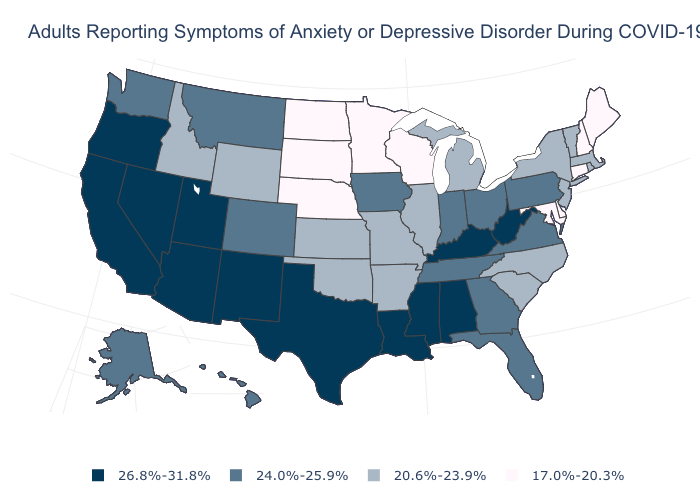Does Virginia have a lower value than Georgia?
Concise answer only. No. What is the value of Alaska?
Give a very brief answer. 24.0%-25.9%. Which states have the highest value in the USA?
Answer briefly. Alabama, Arizona, California, Kentucky, Louisiana, Mississippi, Nevada, New Mexico, Oregon, Texas, Utah, West Virginia. Does Kentucky have a higher value than Indiana?
Answer briefly. Yes. What is the value of Wyoming?
Keep it brief. 20.6%-23.9%. Name the states that have a value in the range 26.8%-31.8%?
Write a very short answer. Alabama, Arizona, California, Kentucky, Louisiana, Mississippi, Nevada, New Mexico, Oregon, Texas, Utah, West Virginia. What is the value of Colorado?
Keep it brief. 24.0%-25.9%. Among the states that border Kansas , does Colorado have the highest value?
Concise answer only. Yes. What is the lowest value in the USA?
Be succinct. 17.0%-20.3%. Does Texas have the highest value in the South?
Keep it brief. Yes. What is the value of Maine?
Be succinct. 17.0%-20.3%. Among the states that border Georgia , does Tennessee have the highest value?
Give a very brief answer. No. Name the states that have a value in the range 20.6%-23.9%?
Give a very brief answer. Arkansas, Idaho, Illinois, Kansas, Massachusetts, Michigan, Missouri, New Jersey, New York, North Carolina, Oklahoma, Rhode Island, South Carolina, Vermont, Wyoming. Name the states that have a value in the range 24.0%-25.9%?
Write a very short answer. Alaska, Colorado, Florida, Georgia, Hawaii, Indiana, Iowa, Montana, Ohio, Pennsylvania, Tennessee, Virginia, Washington. What is the lowest value in states that border Arizona?
Keep it brief. 24.0%-25.9%. 